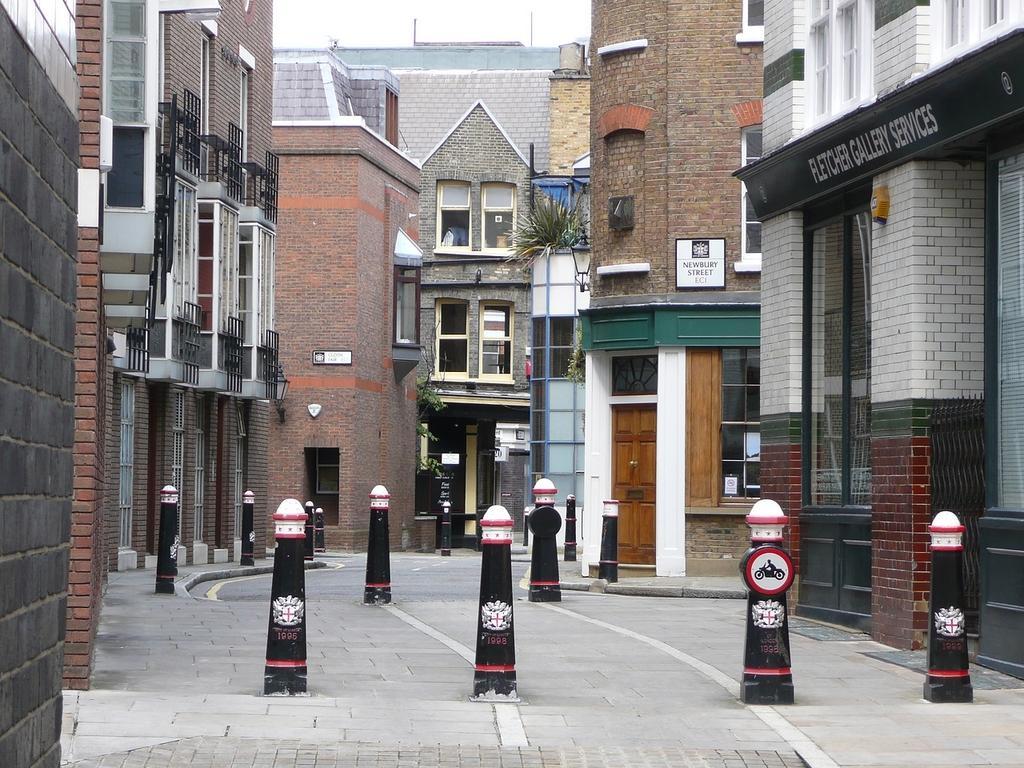Could you give a brief overview of what you see in this image? This picture is clicked in the street. In the middle of the picture, we see small black color poles. On either side of the picture, there are buildings. In the background, we see a building in grey color. 